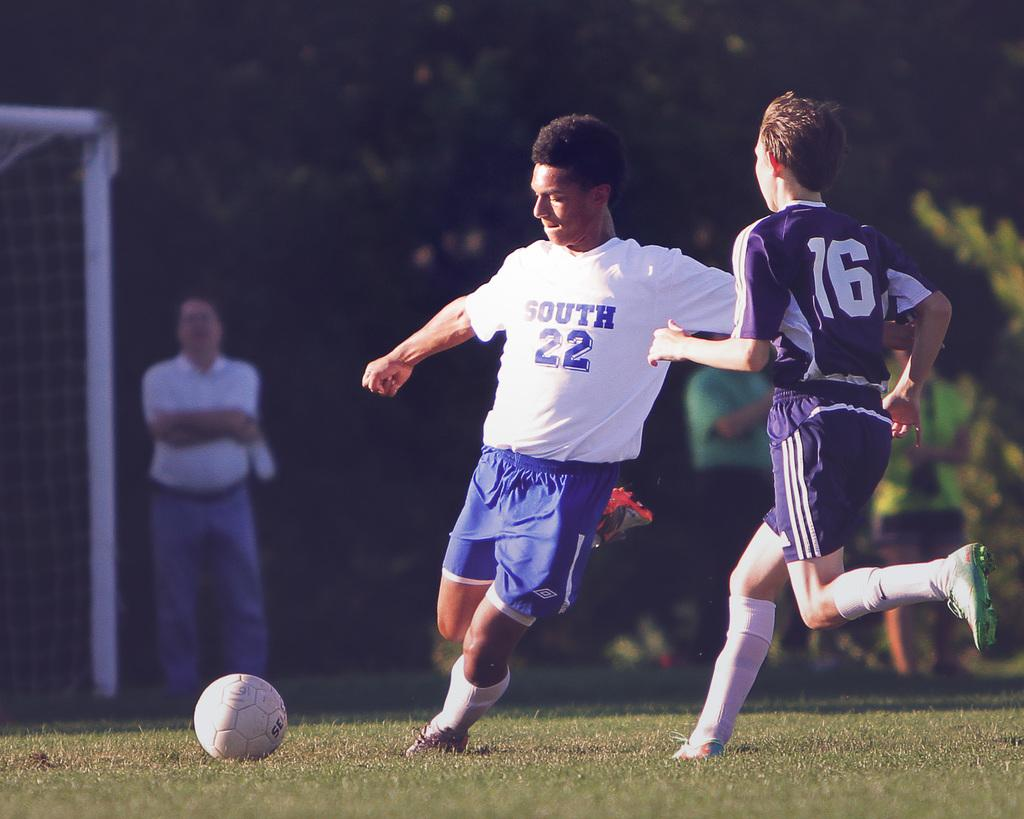<image>
Write a terse but informative summary of the picture. Player number 22 from South tries to take the ball from player number 16. 